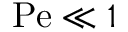<formula> <loc_0><loc_0><loc_500><loc_500>P e \ll 1</formula> 